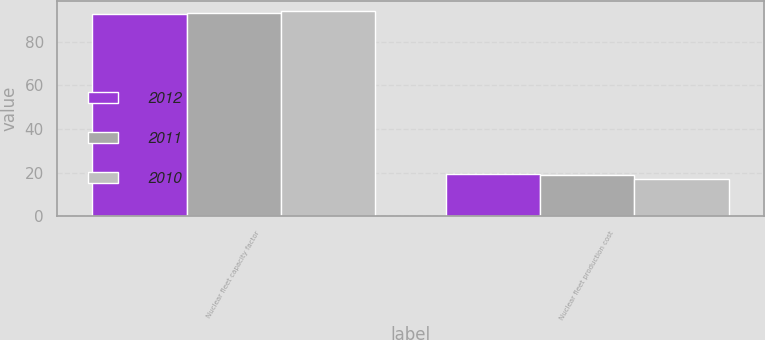Convert chart to OTSL. <chart><loc_0><loc_0><loc_500><loc_500><stacked_bar_chart><ecel><fcel>Nuclear fleet capacity factor<fcel>Nuclear fleet production cost<nl><fcel>2012<fcel>92.7<fcel>19.5<nl><fcel>2011<fcel>93.3<fcel>18.86<nl><fcel>2010<fcel>93.9<fcel>17.31<nl></chart> 